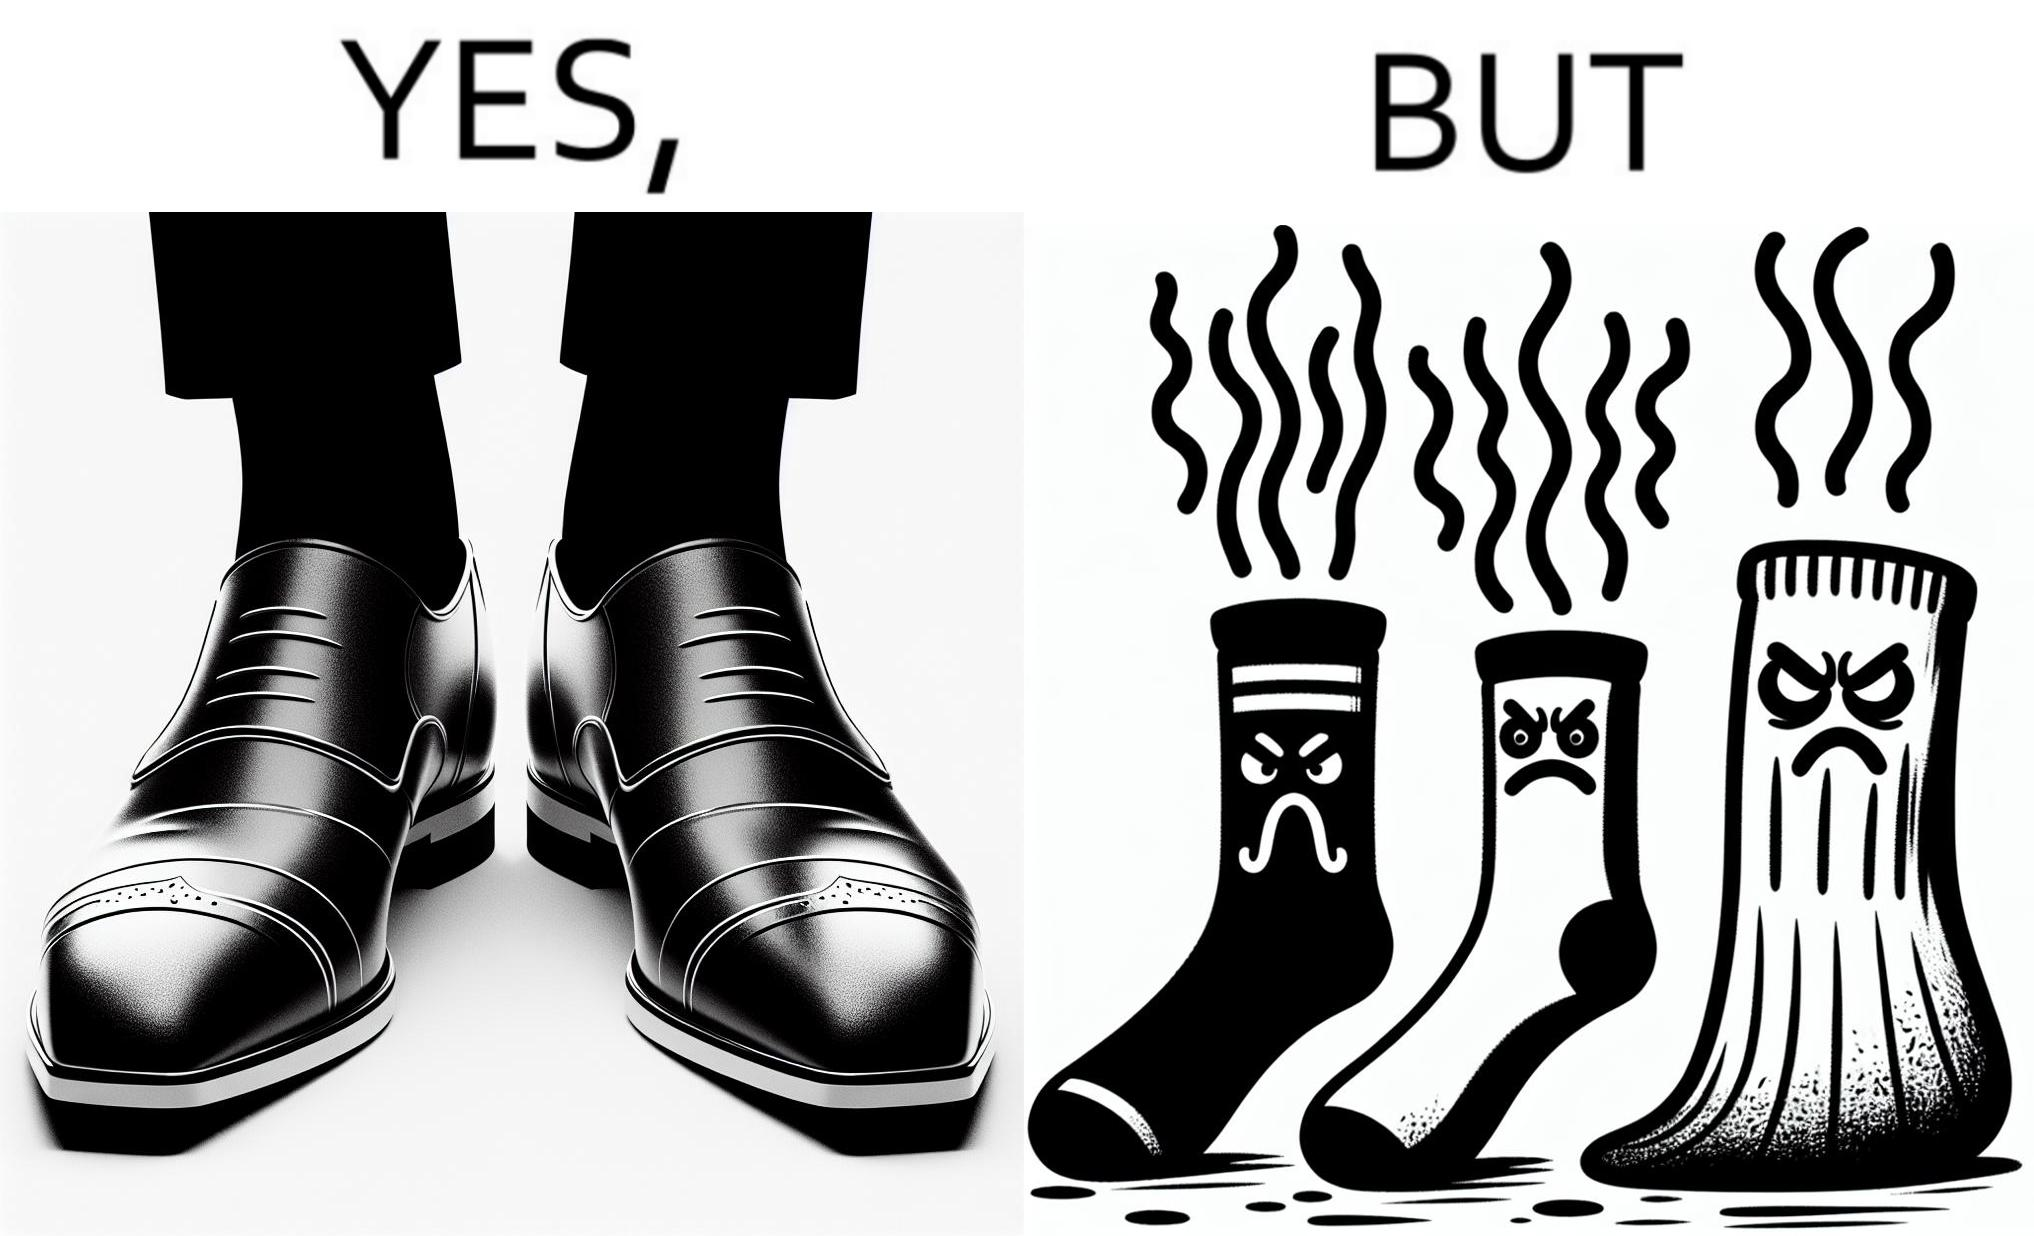Describe the satirical element in this image. The person's shocks is very dirty although the shoes are very clean. Thus there is an irony that not all things are same as they appear. 